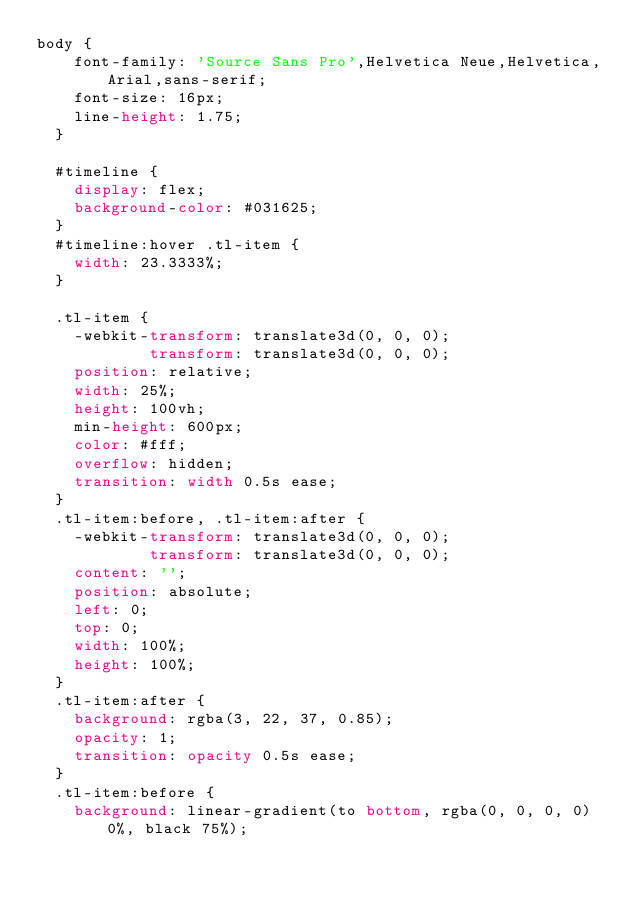Convert code to text. <code><loc_0><loc_0><loc_500><loc_500><_CSS_>body {
    font-family: 'Source Sans Pro',Helvetica Neue,Helvetica,Arial,sans-serif;
    font-size: 16px;
    line-height: 1.75;
  }
  
  #timeline {
    display: flex;
    background-color: #031625;
  }
  #timeline:hover .tl-item {
    width: 23.3333%;
  }
  
  .tl-item {
    -webkit-transform: translate3d(0, 0, 0);
            transform: translate3d(0, 0, 0);
    position: relative;
    width: 25%;
    height: 100vh;
    min-height: 600px;
    color: #fff;
    overflow: hidden;
    transition: width 0.5s ease;
  }
  .tl-item:before, .tl-item:after {
    -webkit-transform: translate3d(0, 0, 0);
            transform: translate3d(0, 0, 0);
    content: '';
    position: absolute;
    left: 0;
    top: 0;
    width: 100%;
    height: 100%;
  }
  .tl-item:after {
    background: rgba(3, 22, 37, 0.85);
    opacity: 1;
    transition: opacity 0.5s ease;
  }
  .tl-item:before {
    background: linear-gradient(to bottom, rgba(0, 0, 0, 0) 0%, black 75%);</code> 